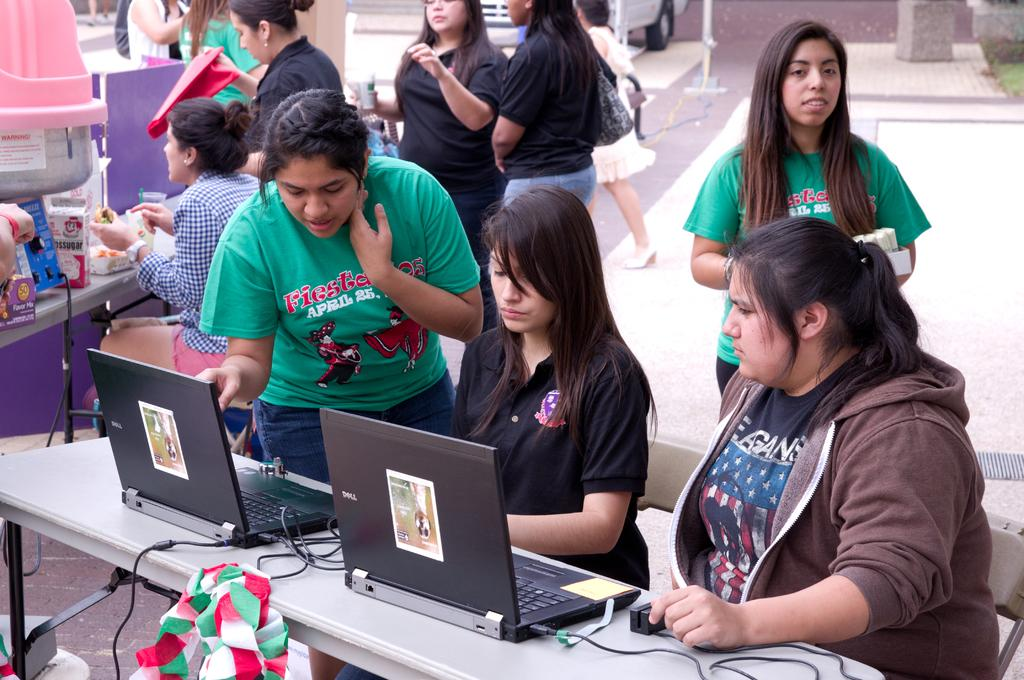<image>
Summarize the visual content of the image. people in front of computers wearing shirts with Fiesta on them 